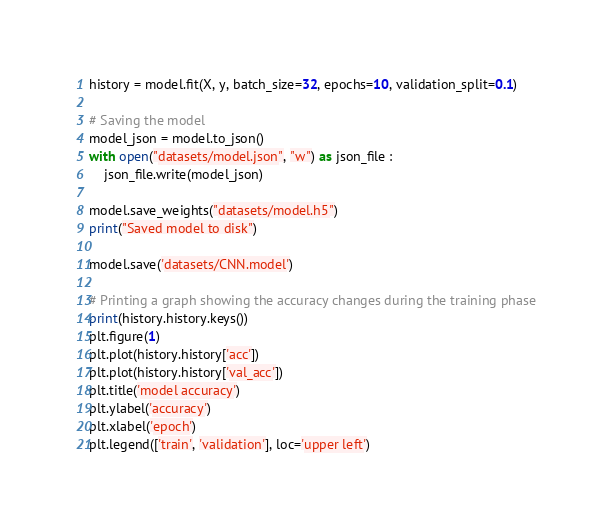Convert code to text. <code><loc_0><loc_0><loc_500><loc_500><_Python_>history = model.fit(X, y, batch_size=32, epochs=10, validation_split=0.1)

# Saving the model
model_json = model.to_json()
with open("datasets/model.json", "w") as json_file :
	json_file.write(model_json)

model.save_weights("datasets/model.h5")
print("Saved model to disk")

model.save('datasets/CNN.model')

# Printing a graph showing the accuracy changes during the training phase
print(history.history.keys())
plt.figure(1)
plt.plot(history.history['acc'])
plt.plot(history.history['val_acc'])
plt.title('model accuracy')
plt.ylabel('accuracy')
plt.xlabel('epoch')
plt.legend(['train', 'validation'], loc='upper left')</code> 